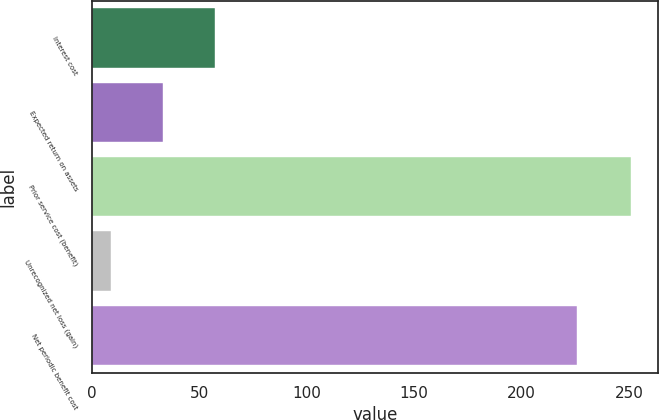Convert chart. <chart><loc_0><loc_0><loc_500><loc_500><bar_chart><fcel>Interest cost<fcel>Expected return on assets<fcel>Prior service cost (benefit)<fcel>Unrecognized net loss (gain)<fcel>Net periodic benefit cost<nl><fcel>57.4<fcel>33.2<fcel>251<fcel>9<fcel>226<nl></chart> 